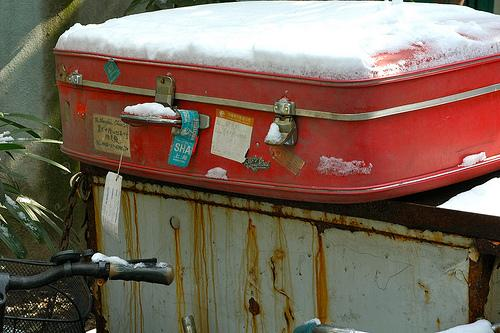What color are the leaves of the bush visible in the image? The leaves of the bush are green. Mention a bicycle part in the image and describe its color and appearance. The handlebar of a bicycle is black and brown and appears to be old. Provide information about the lock on the suitcase and its state. The lock on the red suitcase is opened and missing its luggage mechanism. Explain the appearance of the metal box in the image and its condition. The metal box is large, rusted, and white with stain markings on it. Mention the presence of nature elements in the image and their relationship with the objects. Snow is sitting on top of an old suitcase and the handle, and green leaves of a small tree are seen in the distance. Describe any tags or labels present on the suitcase and their colors. There is a blue tag, a white tag with red trim, and an orange and white paper on the suitcase. Identify the primary object in the image and mention its condition. An old red leather suitcase is covered in snow and has rusted and broken latches. Identify the object with rust in the image and provide a general description. A rusted chain is attached to a box and a rusted metal bin can be seen. What snowy details can you observe about the suitcase and its elements? Snow is on top of the suitcase, covering the handle and surrounding the case. What is the color and state of the suitcase in the image? The suitcase is red and has snow on top, with rusted and broken latches. 